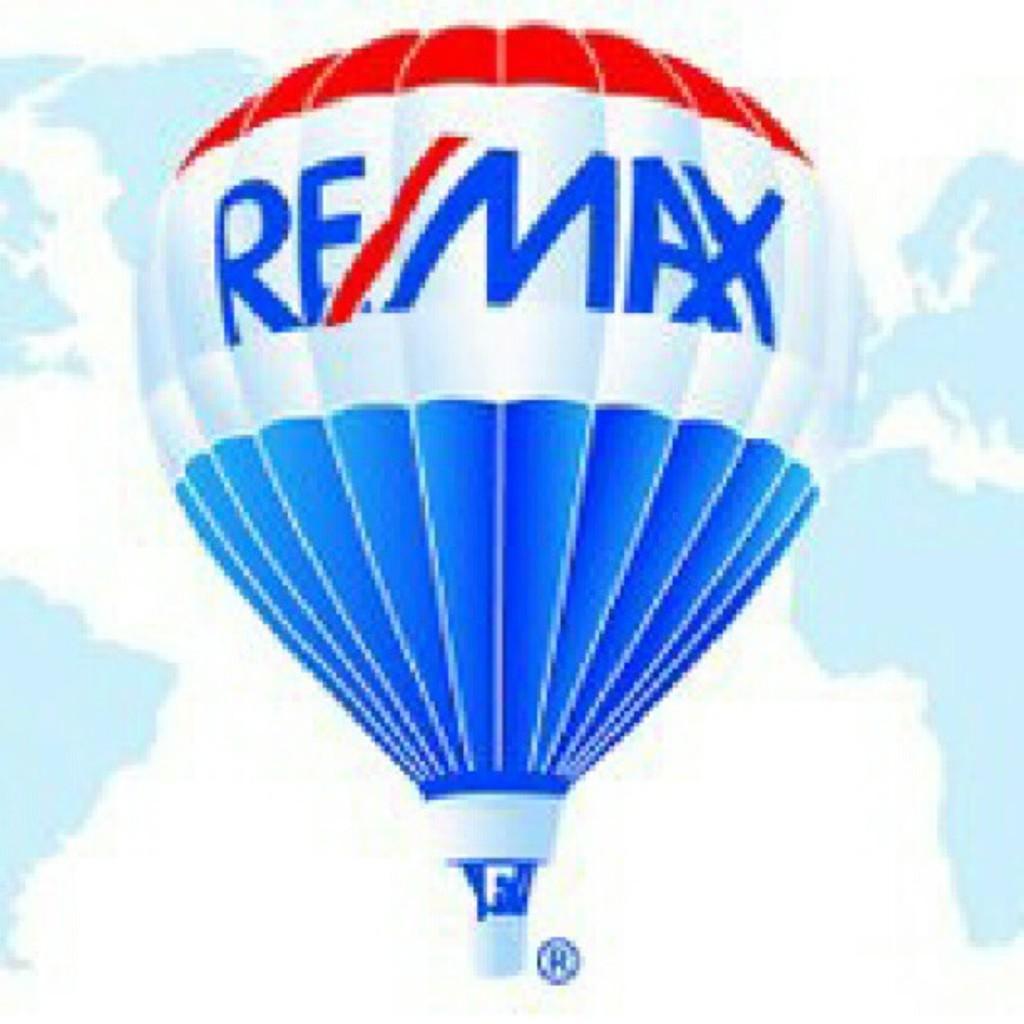Please provide a concise description of this image. In this image I can see a parachute which is in blue and red color, background the sky is in blue and white color. 